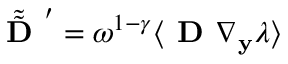<formula> <loc_0><loc_0><loc_500><loc_500>\tilde { \tilde { D } } ^ { \prime } = \omega ^ { 1 - \gamma } \langle D \nabla _ { \mathbf y } \lambda \rangle</formula> 